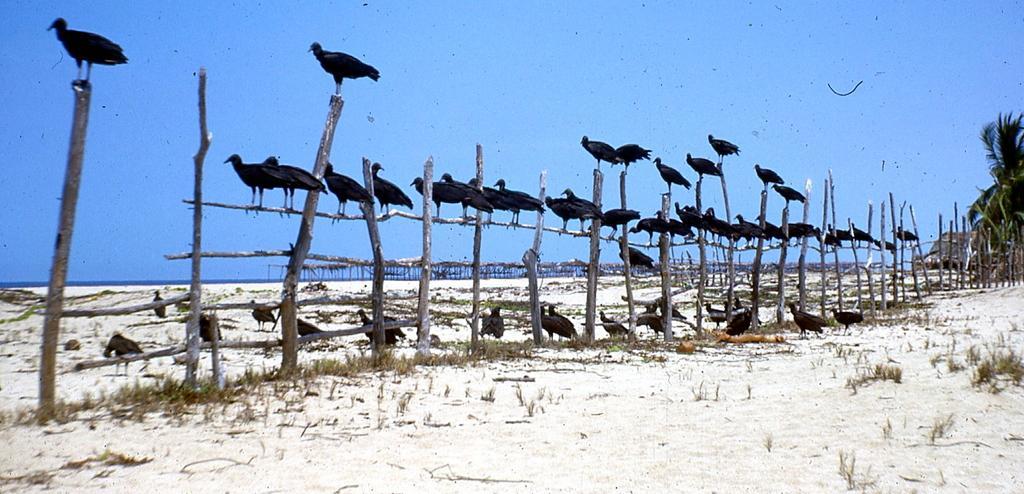How would you summarize this image in a sentence or two? As we can see in the image there are birds, trees, fence and sky. 